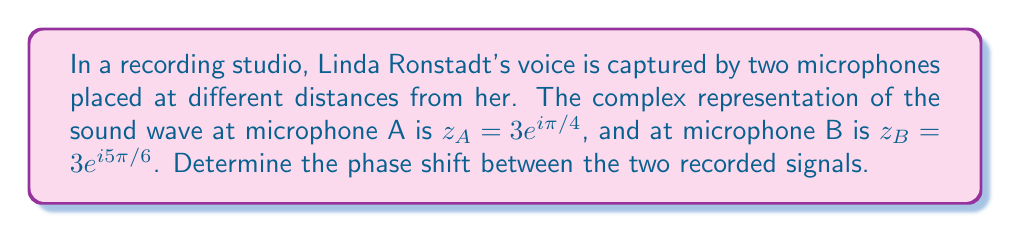Provide a solution to this math problem. To find the phase shift between the two signals, we need to follow these steps:

1) The complex numbers are given in polar form: $z = re^{i\theta}$, where $r$ is the amplitude and $\theta$ is the phase angle.

2) For microphone A: $z_A = 3e^{i\pi/4}$
   For microphone B: $z_B = 3e^{i5\pi/6}$

3) The phase angles are:
   $\theta_A = \pi/4$
   $\theta_B = 5\pi/6$

4) The phase shift is the difference between these angles:
   $$\text{Phase shift} = \theta_B - \theta_A = \frac{5\pi}{6} - \frac{\pi}{4}$$

5) To subtract fractions, we need a common denominator:
   $$\frac{5\pi}{6} - \frac{\pi}{4} = \frac{10\pi}{12} - \frac{3\pi}{12} = \frac{7\pi}{12}$$

6) This can be simplified to $\frac{7\pi}{12}$ radians.

7) To convert to degrees, multiply by $\frac{180°}{\pi}$:
   $$\frac{7\pi}{12} \cdot \frac{180°}{\pi} = 105°$$

Therefore, the phase shift between the two recorded signals is $\frac{7\pi}{12}$ radians or 105°.
Answer: $\frac{7\pi}{12}$ radians or 105° 